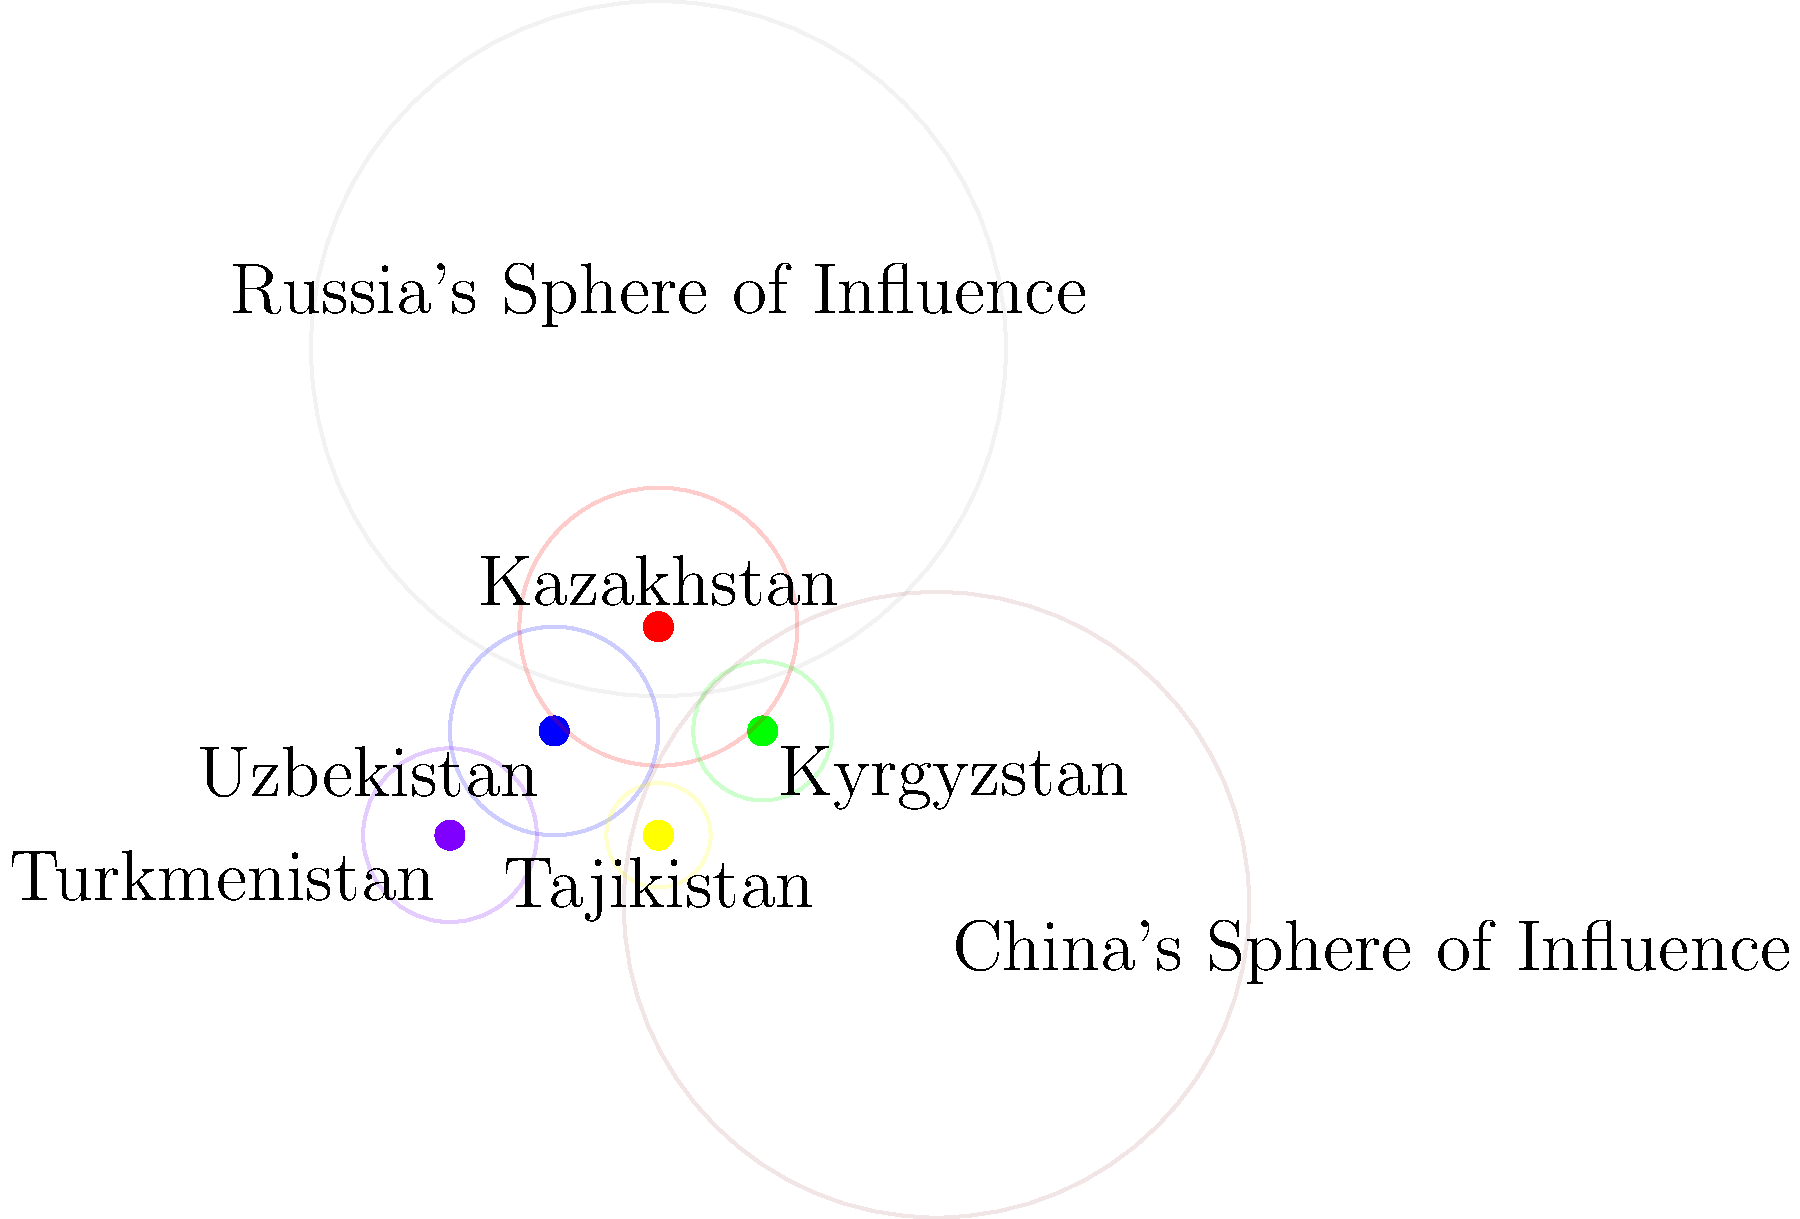Based on the map showing the geopolitical influence of Central Asian countries, which country appears to have the largest sphere of influence within the region, and how does this relate to Alexander Cooley's concept of "Great Games" in Central Asia? To answer this question, we need to analyze the map and relate it to Alexander Cooley's work on Central Asian geopolitics:

1. Observe the map: The colored circles represent each country's sphere of influence.

2. Compare sphere sizes:
   - Kazakhstan (red): Largest circle
   - Uzbekistan (blue): Second largest
   - Turkmenistan (purple): Third largest
   - Kyrgyzstan (green): Fourth largest
   - Tajikistan (yellow): Smallest circle

3. Identify the largest sphere: Kazakhstan has the most extensive regional influence.

4. Relate to Cooley's "Great Games" concept:
   a) Cooley argues that Central Asian states are not merely pawns in great power competition.
   b) He emphasizes their agency in navigating between larger powers (Russia and China, shown on the map).
   c) Kazakhstan's larger sphere aligns with Cooley's view of it as a pivotal player in the region.

5. Consider external influences:
   - Russia's sphere overlaps significantly with Central Asian countries.
   - China's influence is growing but less extensive than Russia's.

6. Reflect on Kazakhstan's role:
   - Its larger sphere suggests greater diplomatic, economic, and political influence.
   - This aligns with Cooley's emphasis on how Central Asian states leverage their position between great powers.

7. Conclusion: Kazakhstan's prominent sphere of influence illustrates Cooley's argument about the complex interplay of regional dynamics and great power competition in Central Asia.
Answer: Kazakhstan, demonstrating Cooley's concept of Central Asian states as active players in regional geopolitics rather than mere pawns of great powers. 